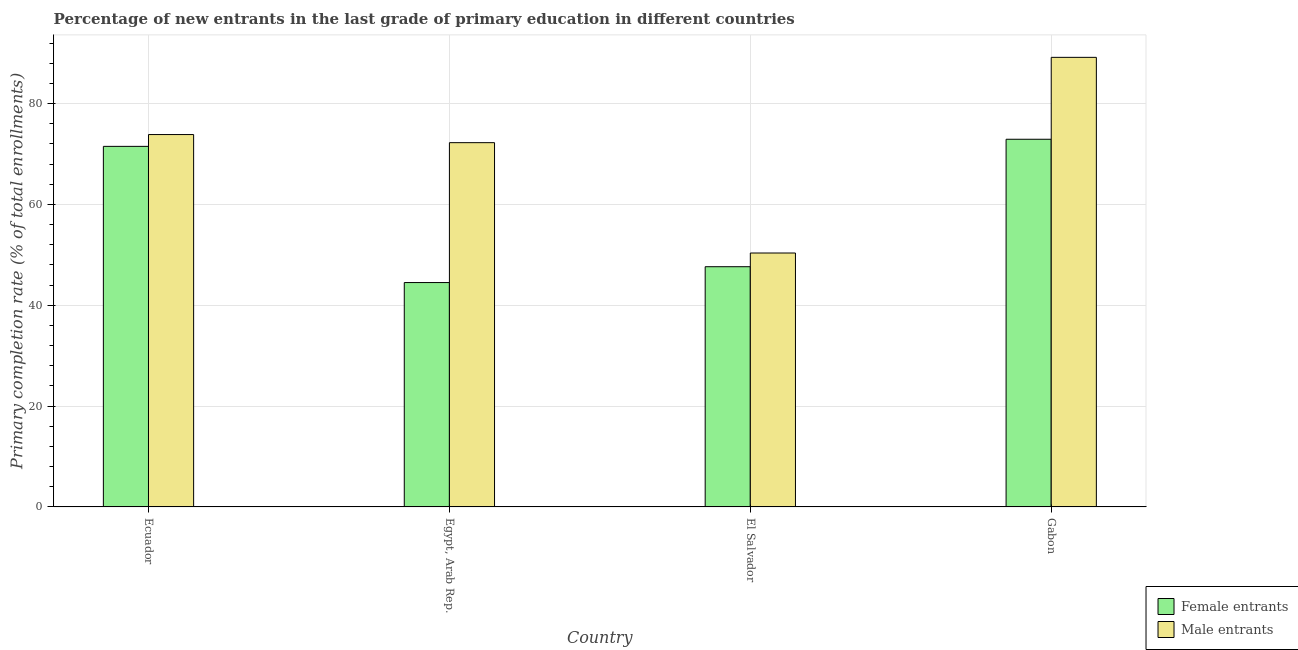How many groups of bars are there?
Your answer should be very brief. 4. How many bars are there on the 2nd tick from the left?
Keep it short and to the point. 2. How many bars are there on the 1st tick from the right?
Give a very brief answer. 2. What is the label of the 1st group of bars from the left?
Ensure brevity in your answer.  Ecuador. In how many cases, is the number of bars for a given country not equal to the number of legend labels?
Your response must be concise. 0. What is the primary completion rate of female entrants in El Salvador?
Make the answer very short. 47.65. Across all countries, what is the maximum primary completion rate of female entrants?
Your response must be concise. 72.93. Across all countries, what is the minimum primary completion rate of female entrants?
Make the answer very short. 44.5. In which country was the primary completion rate of male entrants maximum?
Provide a short and direct response. Gabon. In which country was the primary completion rate of female entrants minimum?
Provide a succinct answer. Egypt, Arab Rep. What is the total primary completion rate of male entrants in the graph?
Your answer should be very brief. 285.64. What is the difference between the primary completion rate of male entrants in Egypt, Arab Rep. and that in Gabon?
Offer a very short reply. -16.92. What is the difference between the primary completion rate of female entrants in Ecuador and the primary completion rate of male entrants in Egypt, Arab Rep.?
Provide a short and direct response. -0.73. What is the average primary completion rate of male entrants per country?
Provide a succinct answer. 71.41. What is the difference between the primary completion rate of male entrants and primary completion rate of female entrants in Gabon?
Your answer should be very brief. 16.24. What is the ratio of the primary completion rate of female entrants in Ecuador to that in Gabon?
Your answer should be very brief. 0.98. Is the primary completion rate of male entrants in Ecuador less than that in El Salvador?
Your answer should be compact. No. What is the difference between the highest and the second highest primary completion rate of female entrants?
Your response must be concise. 1.41. What is the difference between the highest and the lowest primary completion rate of male entrants?
Keep it short and to the point. 38.81. Is the sum of the primary completion rate of male entrants in El Salvador and Gabon greater than the maximum primary completion rate of female entrants across all countries?
Provide a succinct answer. Yes. What does the 1st bar from the left in Egypt, Arab Rep. represents?
Provide a short and direct response. Female entrants. What does the 1st bar from the right in Ecuador represents?
Your answer should be compact. Male entrants. How many countries are there in the graph?
Your answer should be compact. 4. What is the difference between two consecutive major ticks on the Y-axis?
Give a very brief answer. 20. Does the graph contain grids?
Your answer should be compact. Yes. What is the title of the graph?
Offer a very short reply. Percentage of new entrants in the last grade of primary education in different countries. What is the label or title of the Y-axis?
Give a very brief answer. Primary completion rate (% of total enrollments). What is the Primary completion rate (% of total enrollments) in Female entrants in Ecuador?
Provide a short and direct response. 71.52. What is the Primary completion rate (% of total enrollments) in Male entrants in Ecuador?
Make the answer very short. 73.86. What is the Primary completion rate (% of total enrollments) in Female entrants in Egypt, Arab Rep.?
Your response must be concise. 44.5. What is the Primary completion rate (% of total enrollments) in Male entrants in Egypt, Arab Rep.?
Provide a short and direct response. 72.25. What is the Primary completion rate (% of total enrollments) in Female entrants in El Salvador?
Give a very brief answer. 47.65. What is the Primary completion rate (% of total enrollments) in Male entrants in El Salvador?
Your answer should be very brief. 50.36. What is the Primary completion rate (% of total enrollments) in Female entrants in Gabon?
Your response must be concise. 72.93. What is the Primary completion rate (% of total enrollments) in Male entrants in Gabon?
Give a very brief answer. 89.17. Across all countries, what is the maximum Primary completion rate (% of total enrollments) in Female entrants?
Provide a succinct answer. 72.93. Across all countries, what is the maximum Primary completion rate (% of total enrollments) of Male entrants?
Give a very brief answer. 89.17. Across all countries, what is the minimum Primary completion rate (% of total enrollments) in Female entrants?
Your answer should be very brief. 44.5. Across all countries, what is the minimum Primary completion rate (% of total enrollments) of Male entrants?
Give a very brief answer. 50.36. What is the total Primary completion rate (% of total enrollments) of Female entrants in the graph?
Your answer should be very brief. 236.6. What is the total Primary completion rate (% of total enrollments) in Male entrants in the graph?
Give a very brief answer. 285.64. What is the difference between the Primary completion rate (% of total enrollments) in Female entrants in Ecuador and that in Egypt, Arab Rep.?
Offer a very short reply. 27.02. What is the difference between the Primary completion rate (% of total enrollments) of Male entrants in Ecuador and that in Egypt, Arab Rep.?
Keep it short and to the point. 1.61. What is the difference between the Primary completion rate (% of total enrollments) of Female entrants in Ecuador and that in El Salvador?
Your answer should be very brief. 23.87. What is the difference between the Primary completion rate (% of total enrollments) of Male entrants in Ecuador and that in El Salvador?
Offer a very short reply. 23.49. What is the difference between the Primary completion rate (% of total enrollments) in Female entrants in Ecuador and that in Gabon?
Ensure brevity in your answer.  -1.41. What is the difference between the Primary completion rate (% of total enrollments) of Male entrants in Ecuador and that in Gabon?
Your answer should be compact. -15.31. What is the difference between the Primary completion rate (% of total enrollments) of Female entrants in Egypt, Arab Rep. and that in El Salvador?
Offer a very short reply. -3.15. What is the difference between the Primary completion rate (% of total enrollments) in Male entrants in Egypt, Arab Rep. and that in El Salvador?
Provide a short and direct response. 21.88. What is the difference between the Primary completion rate (% of total enrollments) of Female entrants in Egypt, Arab Rep. and that in Gabon?
Provide a short and direct response. -28.43. What is the difference between the Primary completion rate (% of total enrollments) of Male entrants in Egypt, Arab Rep. and that in Gabon?
Offer a very short reply. -16.92. What is the difference between the Primary completion rate (% of total enrollments) in Female entrants in El Salvador and that in Gabon?
Keep it short and to the point. -25.28. What is the difference between the Primary completion rate (% of total enrollments) of Male entrants in El Salvador and that in Gabon?
Your answer should be very brief. -38.81. What is the difference between the Primary completion rate (% of total enrollments) of Female entrants in Ecuador and the Primary completion rate (% of total enrollments) of Male entrants in Egypt, Arab Rep.?
Your answer should be compact. -0.73. What is the difference between the Primary completion rate (% of total enrollments) of Female entrants in Ecuador and the Primary completion rate (% of total enrollments) of Male entrants in El Salvador?
Keep it short and to the point. 21.15. What is the difference between the Primary completion rate (% of total enrollments) of Female entrants in Ecuador and the Primary completion rate (% of total enrollments) of Male entrants in Gabon?
Provide a succinct answer. -17.65. What is the difference between the Primary completion rate (% of total enrollments) in Female entrants in Egypt, Arab Rep. and the Primary completion rate (% of total enrollments) in Male entrants in El Salvador?
Provide a succinct answer. -5.86. What is the difference between the Primary completion rate (% of total enrollments) of Female entrants in Egypt, Arab Rep. and the Primary completion rate (% of total enrollments) of Male entrants in Gabon?
Make the answer very short. -44.67. What is the difference between the Primary completion rate (% of total enrollments) in Female entrants in El Salvador and the Primary completion rate (% of total enrollments) in Male entrants in Gabon?
Provide a short and direct response. -41.52. What is the average Primary completion rate (% of total enrollments) of Female entrants per country?
Keep it short and to the point. 59.15. What is the average Primary completion rate (% of total enrollments) in Male entrants per country?
Make the answer very short. 71.41. What is the difference between the Primary completion rate (% of total enrollments) of Female entrants and Primary completion rate (% of total enrollments) of Male entrants in Ecuador?
Keep it short and to the point. -2.34. What is the difference between the Primary completion rate (% of total enrollments) of Female entrants and Primary completion rate (% of total enrollments) of Male entrants in Egypt, Arab Rep.?
Give a very brief answer. -27.75. What is the difference between the Primary completion rate (% of total enrollments) of Female entrants and Primary completion rate (% of total enrollments) of Male entrants in El Salvador?
Ensure brevity in your answer.  -2.72. What is the difference between the Primary completion rate (% of total enrollments) in Female entrants and Primary completion rate (% of total enrollments) in Male entrants in Gabon?
Provide a succinct answer. -16.24. What is the ratio of the Primary completion rate (% of total enrollments) of Female entrants in Ecuador to that in Egypt, Arab Rep.?
Keep it short and to the point. 1.61. What is the ratio of the Primary completion rate (% of total enrollments) in Male entrants in Ecuador to that in Egypt, Arab Rep.?
Keep it short and to the point. 1.02. What is the ratio of the Primary completion rate (% of total enrollments) in Female entrants in Ecuador to that in El Salvador?
Offer a very short reply. 1.5. What is the ratio of the Primary completion rate (% of total enrollments) of Male entrants in Ecuador to that in El Salvador?
Your answer should be very brief. 1.47. What is the ratio of the Primary completion rate (% of total enrollments) of Female entrants in Ecuador to that in Gabon?
Keep it short and to the point. 0.98. What is the ratio of the Primary completion rate (% of total enrollments) in Male entrants in Ecuador to that in Gabon?
Provide a short and direct response. 0.83. What is the ratio of the Primary completion rate (% of total enrollments) in Female entrants in Egypt, Arab Rep. to that in El Salvador?
Your response must be concise. 0.93. What is the ratio of the Primary completion rate (% of total enrollments) in Male entrants in Egypt, Arab Rep. to that in El Salvador?
Make the answer very short. 1.43. What is the ratio of the Primary completion rate (% of total enrollments) of Female entrants in Egypt, Arab Rep. to that in Gabon?
Your answer should be compact. 0.61. What is the ratio of the Primary completion rate (% of total enrollments) of Male entrants in Egypt, Arab Rep. to that in Gabon?
Provide a short and direct response. 0.81. What is the ratio of the Primary completion rate (% of total enrollments) of Female entrants in El Salvador to that in Gabon?
Your answer should be very brief. 0.65. What is the ratio of the Primary completion rate (% of total enrollments) of Male entrants in El Salvador to that in Gabon?
Your answer should be very brief. 0.56. What is the difference between the highest and the second highest Primary completion rate (% of total enrollments) in Female entrants?
Make the answer very short. 1.41. What is the difference between the highest and the second highest Primary completion rate (% of total enrollments) in Male entrants?
Make the answer very short. 15.31. What is the difference between the highest and the lowest Primary completion rate (% of total enrollments) of Female entrants?
Offer a very short reply. 28.43. What is the difference between the highest and the lowest Primary completion rate (% of total enrollments) of Male entrants?
Offer a very short reply. 38.81. 